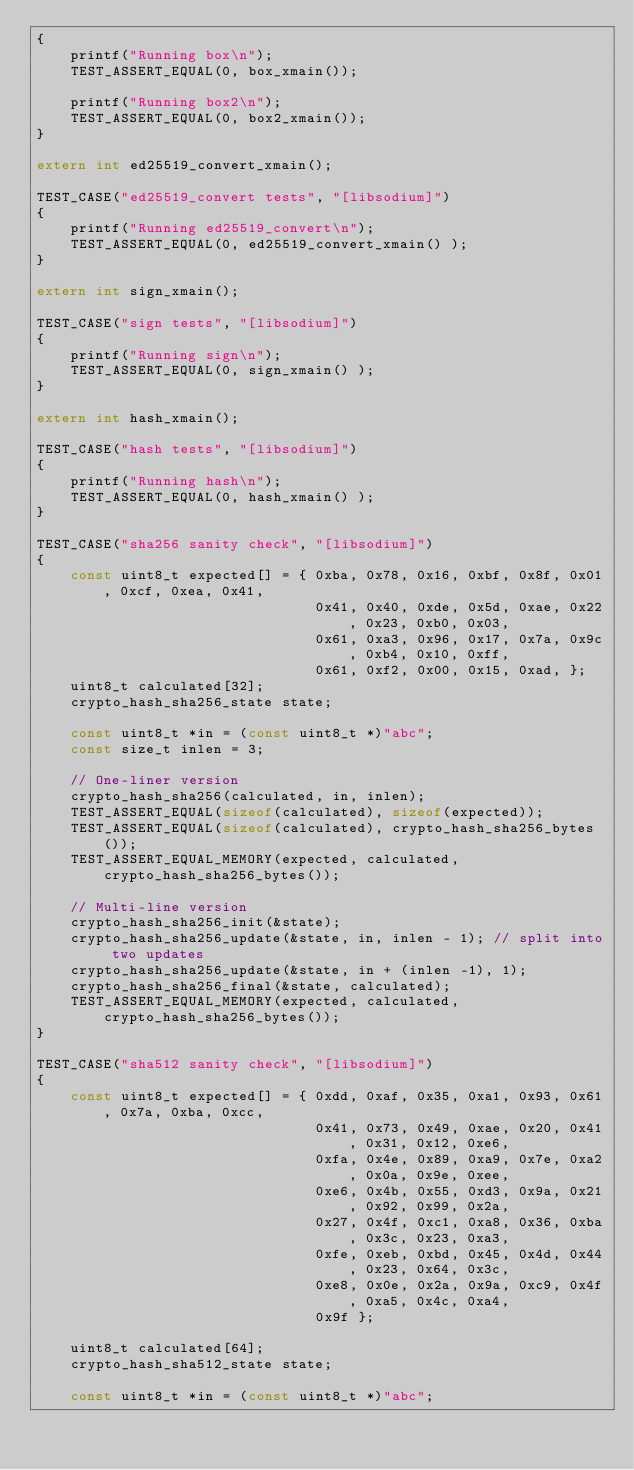Convert code to text. <code><loc_0><loc_0><loc_500><loc_500><_C_>{
    printf("Running box\n");
    TEST_ASSERT_EQUAL(0, box_xmain());

    printf("Running box2\n");
    TEST_ASSERT_EQUAL(0, box2_xmain());
}

extern int ed25519_convert_xmain();

TEST_CASE("ed25519_convert tests", "[libsodium]")
{
    printf("Running ed25519_convert\n");
    TEST_ASSERT_EQUAL(0, ed25519_convert_xmain() );
}

extern int sign_xmain();

TEST_CASE("sign tests", "[libsodium]")
{
    printf("Running sign\n");
    TEST_ASSERT_EQUAL(0, sign_xmain() );
}

extern int hash_xmain();

TEST_CASE("hash tests", "[libsodium]")
{
    printf("Running hash\n");
    TEST_ASSERT_EQUAL(0, hash_xmain() );
}

TEST_CASE("sha256 sanity check", "[libsodium]")
{
    const uint8_t expected[] = { 0xba, 0x78, 0x16, 0xbf, 0x8f, 0x01, 0xcf, 0xea, 0x41,
                                 0x41, 0x40, 0xde, 0x5d, 0xae, 0x22, 0x23, 0xb0, 0x03,
                                 0x61, 0xa3, 0x96, 0x17, 0x7a, 0x9c, 0xb4, 0x10, 0xff,
                                 0x61, 0xf2, 0x00, 0x15, 0xad, };
    uint8_t calculated[32];
    crypto_hash_sha256_state state;

    const uint8_t *in = (const uint8_t *)"abc";
    const size_t inlen = 3;

    // One-liner version
    crypto_hash_sha256(calculated, in, inlen);
    TEST_ASSERT_EQUAL(sizeof(calculated), sizeof(expected));
    TEST_ASSERT_EQUAL(sizeof(calculated), crypto_hash_sha256_bytes());
    TEST_ASSERT_EQUAL_MEMORY(expected, calculated, crypto_hash_sha256_bytes());

    // Multi-line version
    crypto_hash_sha256_init(&state);
    crypto_hash_sha256_update(&state, in, inlen - 1); // split into two updates
    crypto_hash_sha256_update(&state, in + (inlen -1), 1);
    crypto_hash_sha256_final(&state, calculated);
    TEST_ASSERT_EQUAL_MEMORY(expected, calculated, crypto_hash_sha256_bytes());
}

TEST_CASE("sha512 sanity check", "[libsodium]")
{
    const uint8_t expected[] = { 0xdd, 0xaf, 0x35, 0xa1, 0x93, 0x61, 0x7a, 0xba, 0xcc,
                                 0x41, 0x73, 0x49, 0xae, 0x20, 0x41, 0x31, 0x12, 0xe6,
                                 0xfa, 0x4e, 0x89, 0xa9, 0x7e, 0xa2, 0x0a, 0x9e, 0xee,
                                 0xe6, 0x4b, 0x55, 0xd3, 0x9a, 0x21, 0x92, 0x99, 0x2a,
                                 0x27, 0x4f, 0xc1, 0xa8, 0x36, 0xba, 0x3c, 0x23, 0xa3,
                                 0xfe, 0xeb, 0xbd, 0x45, 0x4d, 0x44, 0x23, 0x64, 0x3c,
                                 0xe8, 0x0e, 0x2a, 0x9a, 0xc9, 0x4f, 0xa5, 0x4c, 0xa4,
                                 0x9f };

    uint8_t calculated[64];
    crypto_hash_sha512_state state;

    const uint8_t *in = (const uint8_t *)"abc";</code> 